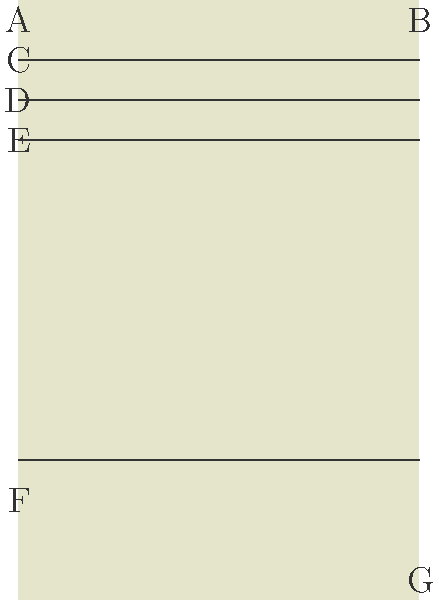In the traditional letter format shown above, which letter corresponds to the sender's address? To identify the sender's address in a traditional letter format, let's examine each part of the letter:

1. Part A: This is typically the return address or sender's address. It's located at the top left corner of the letter.
2. Part B: This area is usually reserved for the date of the letter.
3. Part C: This line is generally used for the recipient's name.
4. Part D: This area is for the recipient's address.
5. Part E: This space is often used for the salutation (e.g., "Dear Sir/Madam").
6. Part F: This large area represents the main body of the letter.
7. Part G: This bottom right section is where the sender typically signs their name.

In a traditional letter format, the sender's address is always placed at the top left corner of the letter. This allows the recipient to easily identify who the letter is from and provides a return address for any necessary correspondence.

Therefore, the sender's address corresponds to the area labeled 'A' in the diagram.
Answer: A 